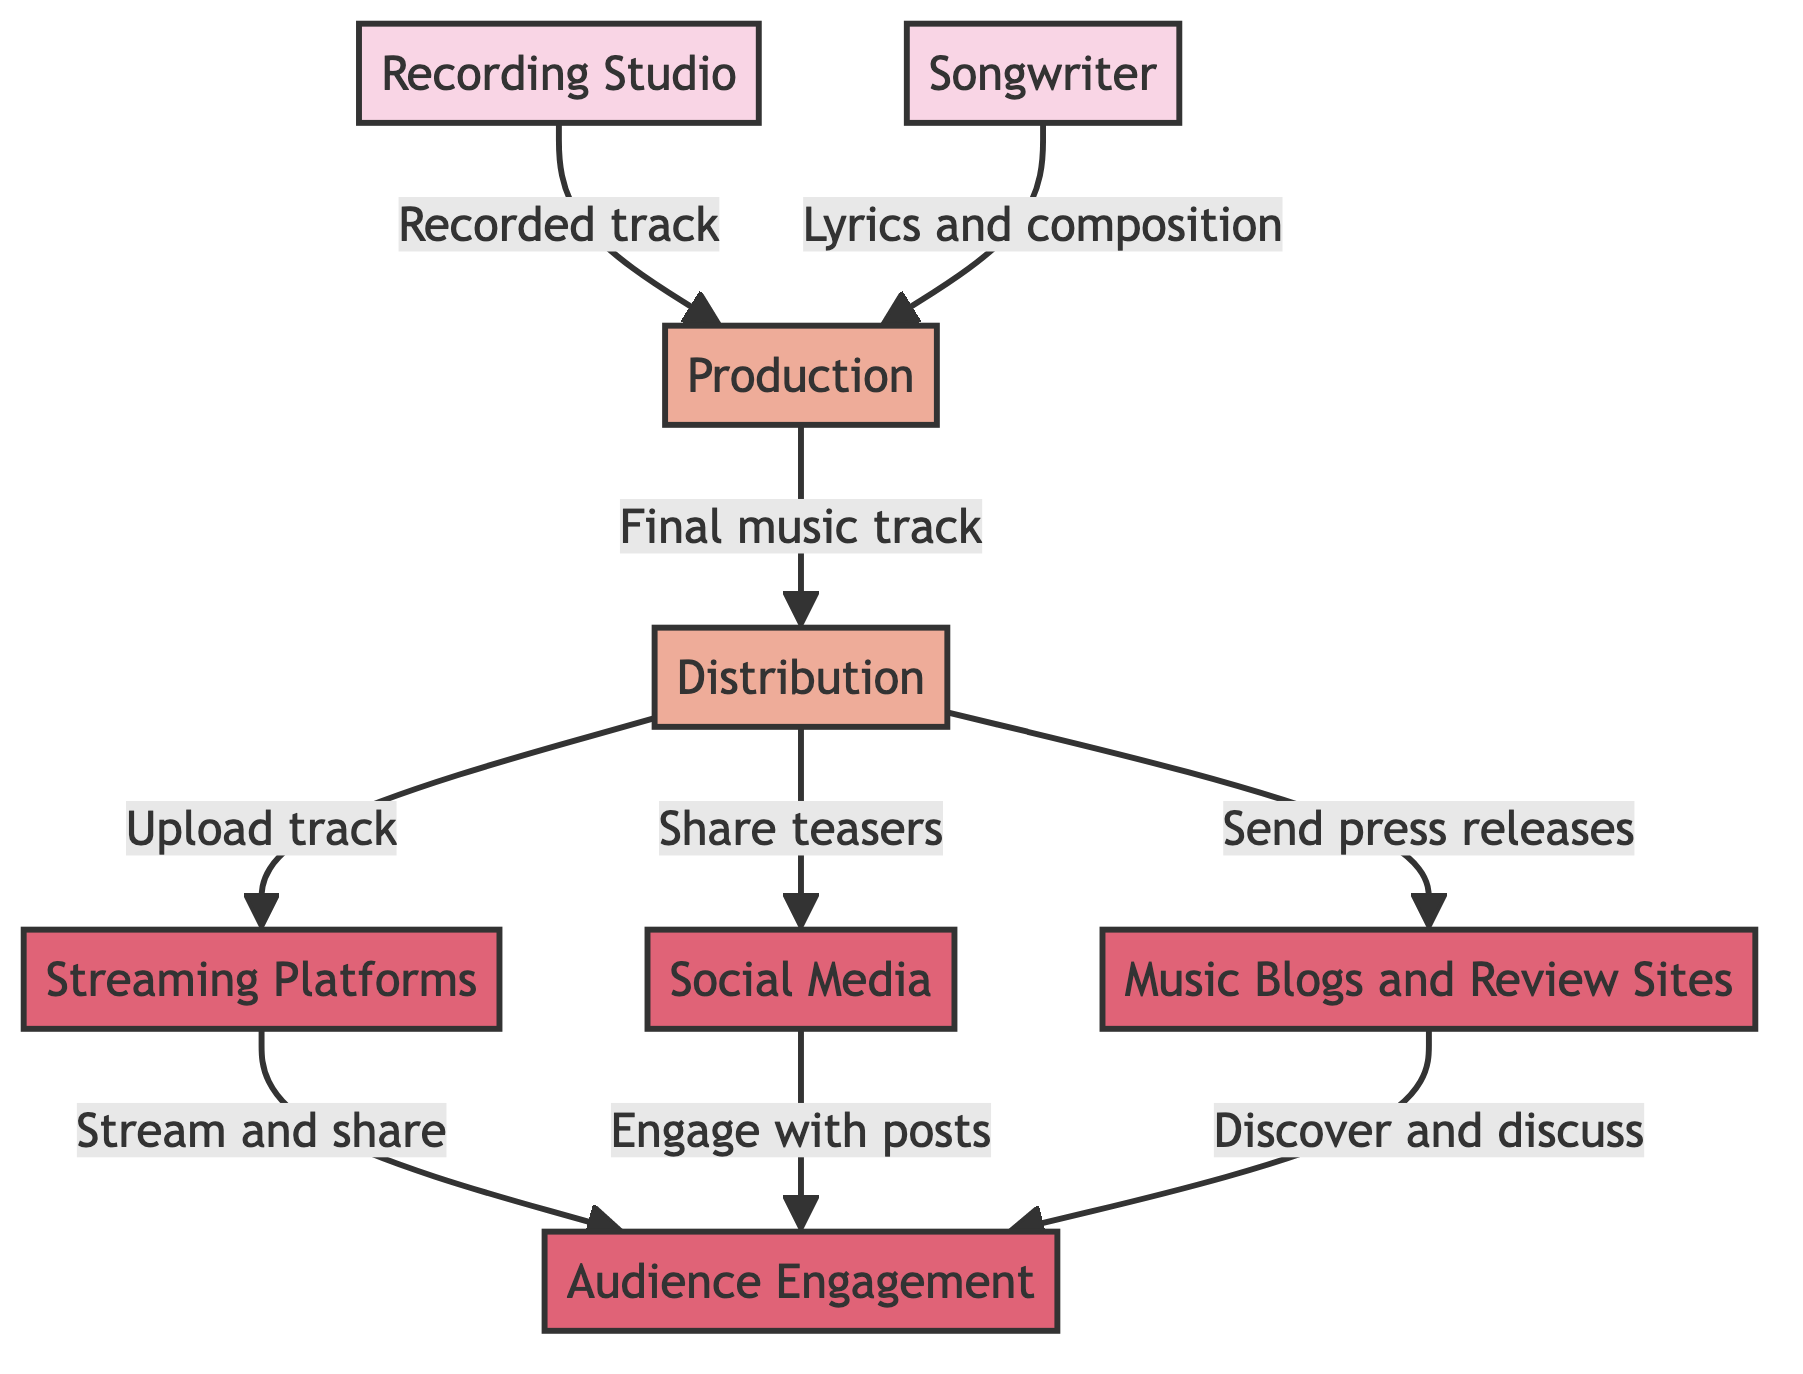What is the first step in the flow? The first step in the flow is the Recorded track being sent from the Recording Studio to Production. This is indicated by the first arrow from the Recording Studio node to the Production node.
Answer: Production How many processes are represented in the diagram? There are three processes depicted in the diagram: Production, Distribution, and Promotion. Counting the nodes labeled as processes confirms this number.
Answer: 3 Which nodes are part of the audience engagement stage? The audience engagement stage is represented by three nodes: Streaming Platforms, Social Media, and Music Blogs and Review Sites. These are directly linked to the Audience Engagement node, showcasing how they contribute to engaging the audience.
Answer: Streaming Platforms, Social Media, Music Blogs and Review Sites What type of data flow occurs between Production and Distribution? The data flow between Production and Distribution involves the Final music track being sent from Production to Distribution, which indicates the completion of the track before it is distributed. This is described in the corresponding arrow linking these two processes.
Answer: Final music track How do Social Media contribute to promoting the track? Social Media contributes to promoting the track by sharing promotional teasers and announcements. This is reflected by the flow from Distribution to Social Media, indicating the specific role of Social Media in the promotional aspect of the distribution process.
Answer: Share teasers Which source provides lyrics and composition for production? The source that provides lyrics and composition for production is the Songwriter. This is explicitly stated in the arrow that flows from the Songwriter to the Production process, indicating their role in the music creation process.
Answer: Songwriter What happens after the music track is uploaded to streaming platforms? After the music track is uploaded to streaming platforms, listeners stream and share the track on those platforms, leading to audience engagement. This information can be traced through the flow from Streaming Platforms to Audience Engagement.
Answer: Stream and share What is the relationship between Music Blogs and Audience Engagement? The relationship is that Music Blogs and Review Sites facilitate audience engagement by allowing readers to discover and discuss the track through reviews and features. This is illustrated by the data flow linking Music Blogs to the Audience Engagement node.
Answer: Discover and discuss 